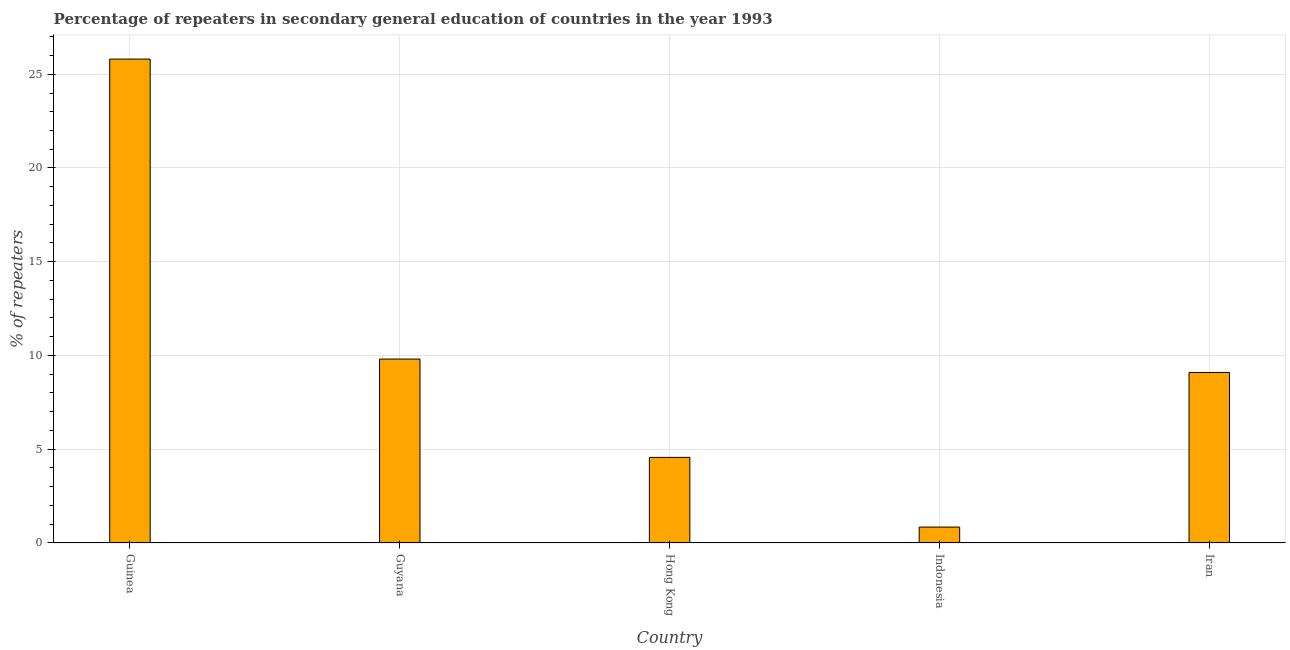Does the graph contain grids?
Provide a succinct answer. Yes. What is the title of the graph?
Offer a terse response. Percentage of repeaters in secondary general education of countries in the year 1993. What is the label or title of the X-axis?
Make the answer very short. Country. What is the label or title of the Y-axis?
Provide a short and direct response. % of repeaters. What is the percentage of repeaters in Guinea?
Provide a short and direct response. 25.81. Across all countries, what is the maximum percentage of repeaters?
Your answer should be very brief. 25.81. Across all countries, what is the minimum percentage of repeaters?
Your answer should be compact. 0.85. In which country was the percentage of repeaters maximum?
Provide a short and direct response. Guinea. In which country was the percentage of repeaters minimum?
Offer a terse response. Indonesia. What is the sum of the percentage of repeaters?
Provide a short and direct response. 50.13. What is the difference between the percentage of repeaters in Guinea and Guyana?
Offer a terse response. 16. What is the average percentage of repeaters per country?
Provide a short and direct response. 10.03. What is the median percentage of repeaters?
Offer a very short reply. 9.1. What is the ratio of the percentage of repeaters in Indonesia to that in Iran?
Your response must be concise. 0.09. Is the difference between the percentage of repeaters in Hong Kong and Indonesia greater than the difference between any two countries?
Your answer should be compact. No. What is the difference between the highest and the second highest percentage of repeaters?
Your answer should be compact. 16. What is the difference between the highest and the lowest percentage of repeaters?
Offer a terse response. 24.96. How many countries are there in the graph?
Offer a very short reply. 5. What is the % of repeaters in Guinea?
Your answer should be very brief. 25.81. What is the % of repeaters in Guyana?
Make the answer very short. 9.81. What is the % of repeaters of Hong Kong?
Provide a short and direct response. 4.57. What is the % of repeaters in Indonesia?
Your response must be concise. 0.85. What is the % of repeaters in Iran?
Your response must be concise. 9.1. What is the difference between the % of repeaters in Guinea and Guyana?
Your answer should be very brief. 16. What is the difference between the % of repeaters in Guinea and Hong Kong?
Make the answer very short. 21.24. What is the difference between the % of repeaters in Guinea and Indonesia?
Offer a very short reply. 24.96. What is the difference between the % of repeaters in Guinea and Iran?
Your response must be concise. 16.71. What is the difference between the % of repeaters in Guyana and Hong Kong?
Your response must be concise. 5.24. What is the difference between the % of repeaters in Guyana and Indonesia?
Ensure brevity in your answer.  8.96. What is the difference between the % of repeaters in Guyana and Iran?
Give a very brief answer. 0.72. What is the difference between the % of repeaters in Hong Kong and Indonesia?
Your answer should be compact. 3.72. What is the difference between the % of repeaters in Hong Kong and Iran?
Keep it short and to the point. -4.53. What is the difference between the % of repeaters in Indonesia and Iran?
Make the answer very short. -8.25. What is the ratio of the % of repeaters in Guinea to that in Guyana?
Make the answer very short. 2.63. What is the ratio of the % of repeaters in Guinea to that in Hong Kong?
Keep it short and to the point. 5.65. What is the ratio of the % of repeaters in Guinea to that in Indonesia?
Offer a very short reply. 30.42. What is the ratio of the % of repeaters in Guinea to that in Iran?
Offer a very short reply. 2.84. What is the ratio of the % of repeaters in Guyana to that in Hong Kong?
Your response must be concise. 2.15. What is the ratio of the % of repeaters in Guyana to that in Indonesia?
Provide a succinct answer. 11.56. What is the ratio of the % of repeaters in Guyana to that in Iran?
Provide a short and direct response. 1.08. What is the ratio of the % of repeaters in Hong Kong to that in Indonesia?
Offer a very short reply. 5.38. What is the ratio of the % of repeaters in Hong Kong to that in Iran?
Offer a very short reply. 0.5. What is the ratio of the % of repeaters in Indonesia to that in Iran?
Make the answer very short. 0.09. 